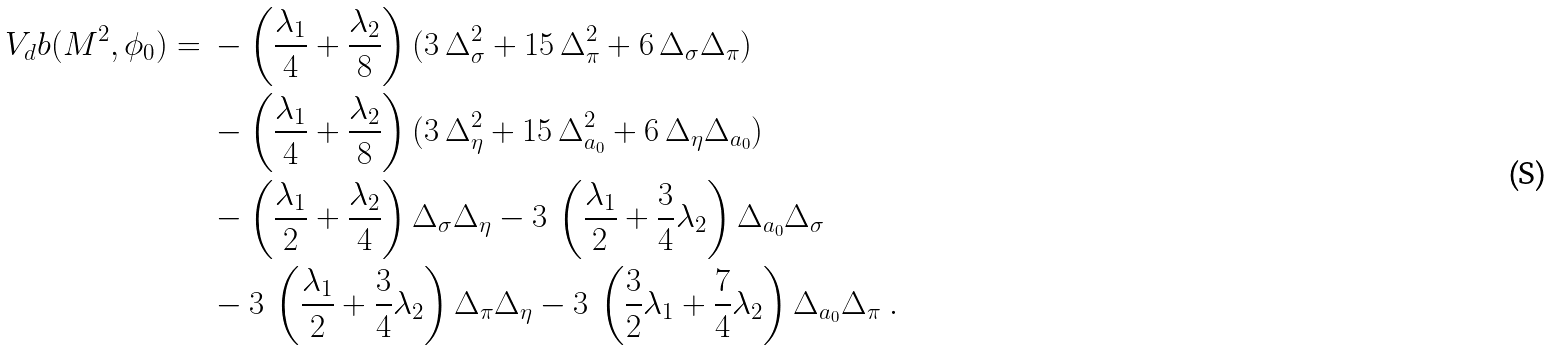Convert formula to latex. <formula><loc_0><loc_0><loc_500><loc_500>V _ { d } b ( { M } ^ { 2 } , \phi _ { 0 } ) = \ & - \left ( \frac { \lambda _ { 1 } } { 4 } + \frac { \lambda _ { 2 } } { 8 } \right ) ( 3 \, \Delta _ { \sigma } ^ { 2 } + 1 5 \, \Delta _ { \pi } ^ { 2 } + 6 \, \Delta _ { \sigma } \Delta _ { \pi } ) \\ & - \left ( \frac { \lambda _ { 1 } } { 4 } + \frac { \lambda _ { 2 } } { 8 } \right ) ( 3 \, \Delta _ { \eta } ^ { 2 } + 1 5 \, \Delta _ { a _ { 0 } } ^ { 2 } + 6 \, \Delta _ { \eta } \Delta _ { a _ { 0 } } ) \\ & - \left ( \frac { \lambda _ { 1 } } { 2 } + \frac { \lambda _ { 2 } } { 4 } \right ) \Delta _ { \sigma } \Delta _ { \eta } - 3 \, \left ( \frac { \lambda _ { 1 } } { 2 } + \frac { 3 } { 4 } \lambda _ { 2 } \right ) \Delta _ { a _ { 0 } } \Delta _ { \sigma } \\ & - 3 \, \left ( \frac { \lambda _ { 1 } } { 2 } + \frac { 3 } { 4 } \lambda _ { 2 } \right ) \Delta _ { \pi } \Delta _ { \eta } - 3 \, \left ( \frac { 3 } { 2 } \lambda _ { 1 } + \frac { 7 } { 4 } \lambda _ { 2 } \right ) \Delta _ { a _ { 0 } } \Delta _ { \pi } \ .</formula> 